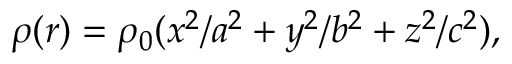Convert formula to latex. <formula><loc_0><loc_0><loc_500><loc_500>\rho ( r ) = \rho _ { 0 } ( x ^ { 2 } / a ^ { 2 } + y ^ { 2 } / b ^ { 2 } + z ^ { 2 } / c ^ { 2 } ) ,</formula> 